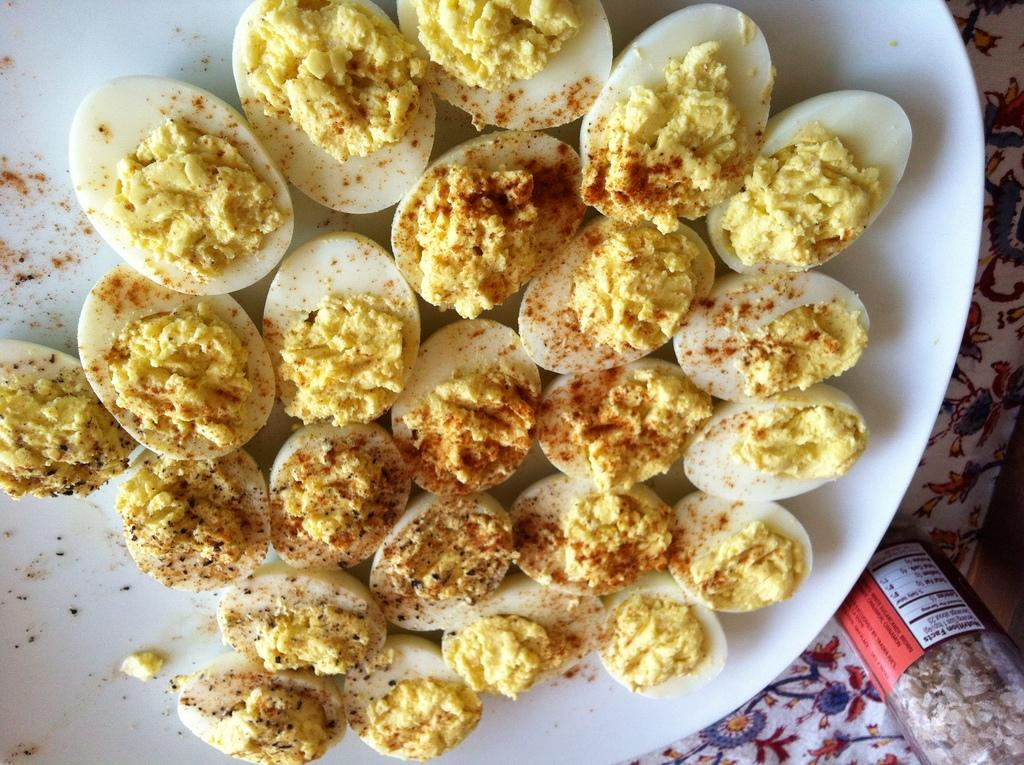What is on the plate that is visible in the image? The plate contains eggs cut into pieces. What seasoning is present on the plate? Chili powder is present on the plate. Where is the bottle located in the image? The bottle is on the right side bottom of the image. What type of room is shown in the image? There is no room visible in the image; it only shows a plate with eggs and chili powder, and a bottle. Can you tell me how many yaks are present in the image? There are no yaks present in the image. 